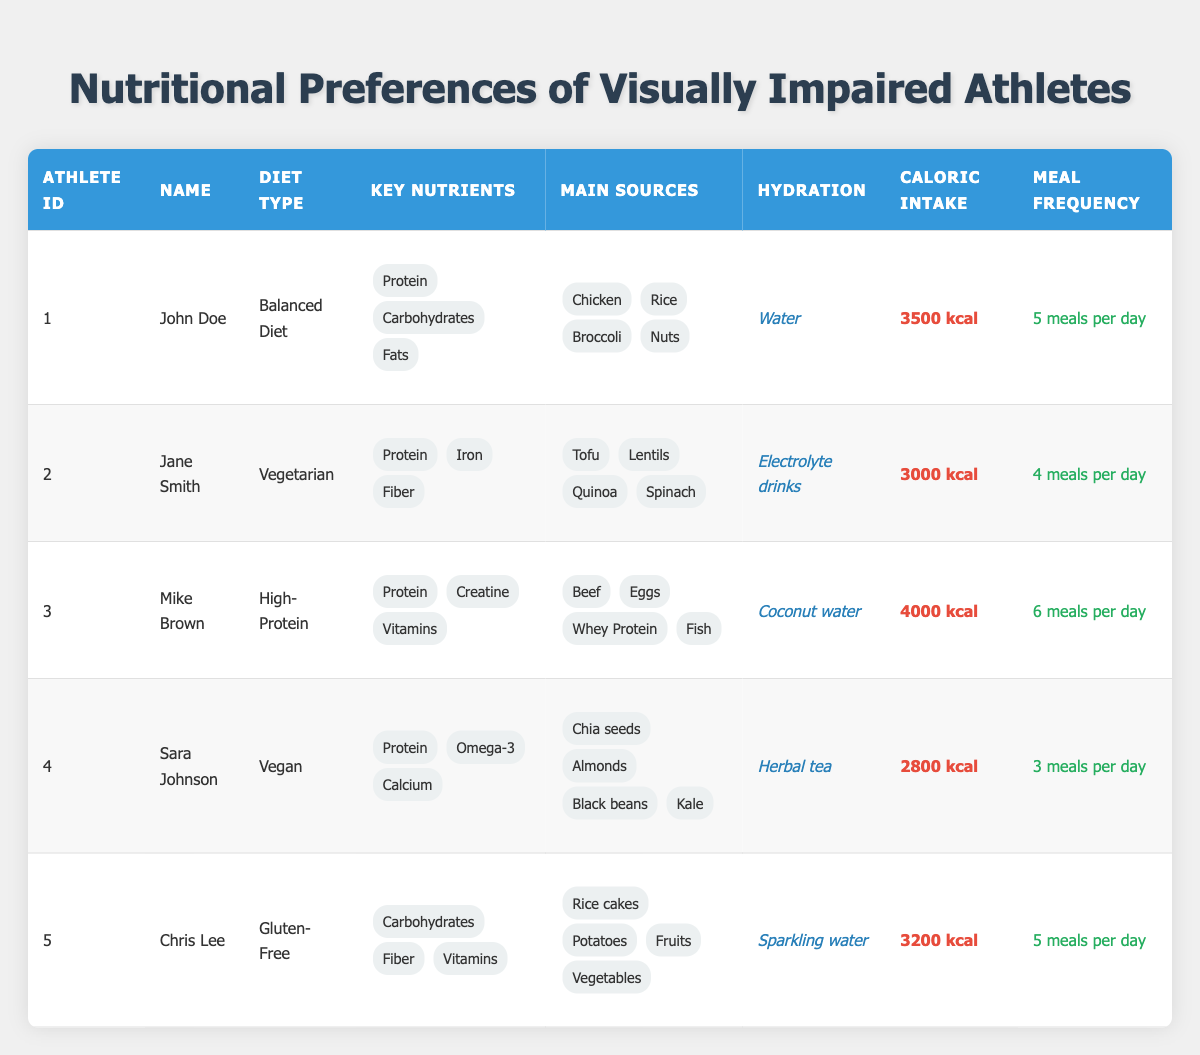What is the diet type of John Doe? The table lists John Doe under Athlete ID 1, and his corresponding diet type is shown as "Balanced Diet."
Answer: Balanced Diet How many meals does Mike Brown have per day? In the row for Mike Brown, identified as Athlete ID 3, the table states he has "6 meals per day."
Answer: 6 meals per day Which athlete has the highest caloric intake? To determine the highest caloric intake, we compare the caloric intake values across all entries. Mike Brown has "4000 kcal," which is higher than the others.
Answer: Mike Brown Are all athletes hydrating with water? Looking at the hydration methods for each athlete, John Doe, Chris Lee, and Mike Brown do not all consume water. Instead, they have other hydration sources like coconut water and electrolyte drinks. Thus, not all are hydrating with water.
Answer: No What is the average caloric intake of the athletes? The caloric intake values are 3500, 3000, 4000, 2800, and 3200 kcal. To find the average, sum these values: 3500 + 3000 + 4000 + 2800 + 3200 = 19500. Divide by the number of athletes, which is 5, resulting in an average of 19500/5 = 3900 kcal.
Answer: 3900 kcal Is Sara Johnson's diet type vegan? The table specifies that Sara Johnson, identified as Athlete ID 4, follows a "Vegan" diet type, confirming that her diet is indeed vegan.
Answer: Yes Which athlete's key nutrients include Omega-3? Searching the key nutrients listed in the row for Sara Johnson (Athlete ID 4), it clearly includes "Omega-3," making her the athlete associated with this nutrient.
Answer: Sara Johnson How many athletes consume more than 5 meals per day? By examining the meal frequency of all athletes, only Mike Brown is recorded with "6 meals per day." Therefore, only one athlete meets the criteria of consuming more than 5 meals.
Answer: 1 